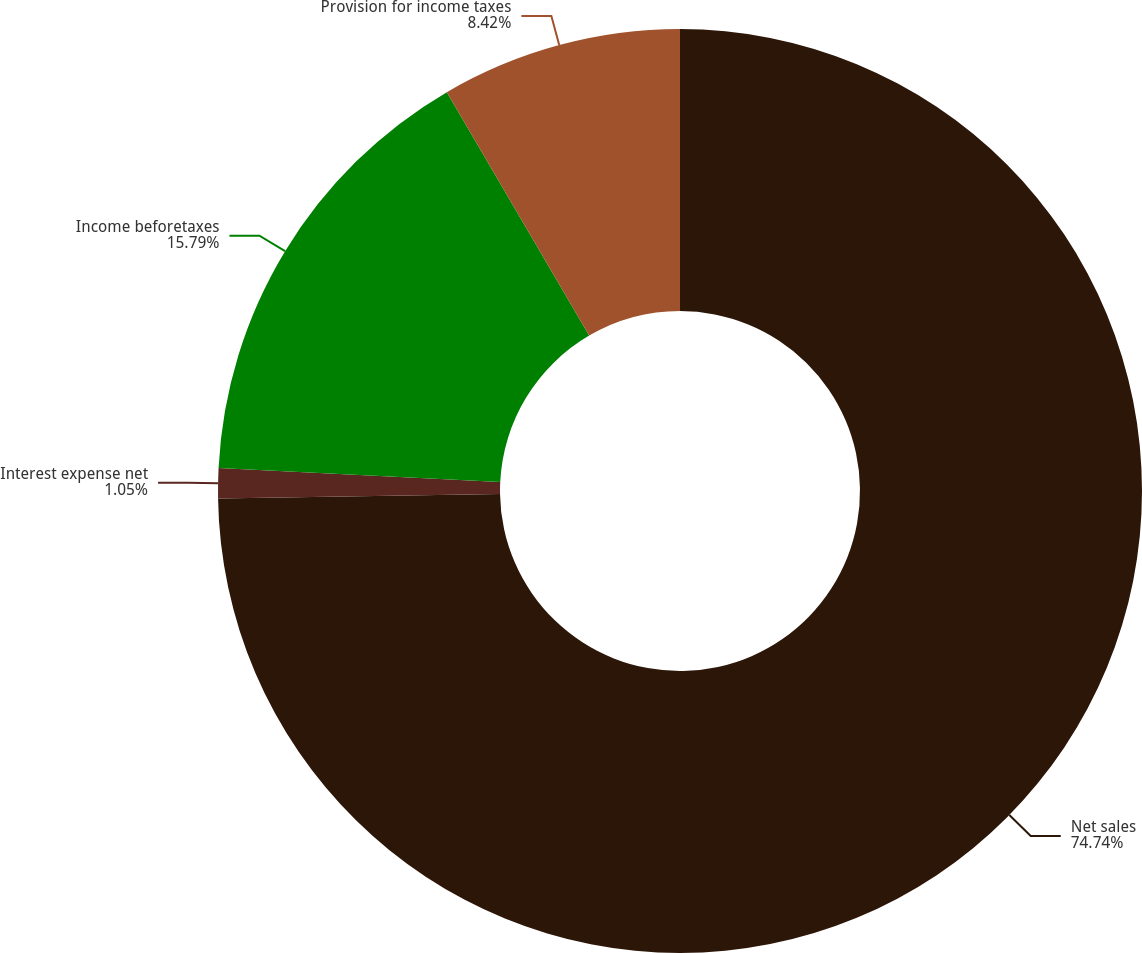Convert chart to OTSL. <chart><loc_0><loc_0><loc_500><loc_500><pie_chart><fcel>Net sales<fcel>Interest expense net<fcel>Income beforetaxes<fcel>Provision for income taxes<nl><fcel>74.74%<fcel>1.05%<fcel>15.79%<fcel>8.42%<nl></chart> 